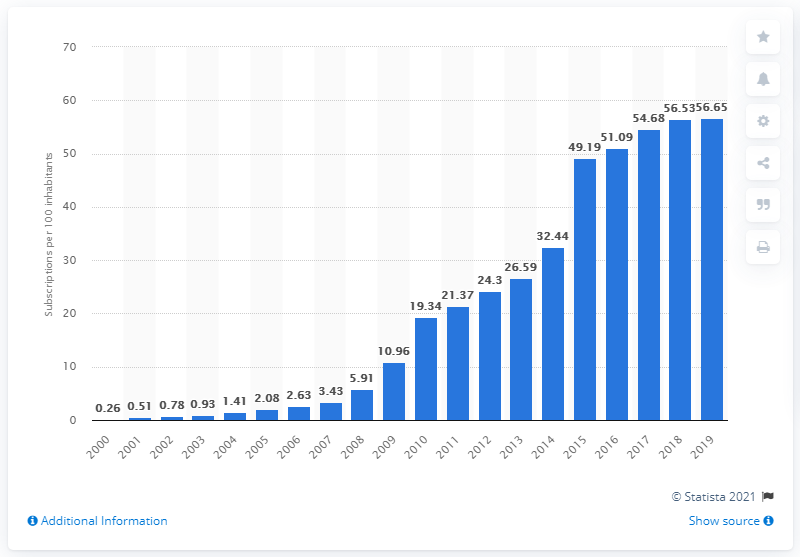Give some essential details in this illustration. There were an estimated 56.65 mobile subscriptions registered for every 100 people in Burundi between 2000 and 2019. 